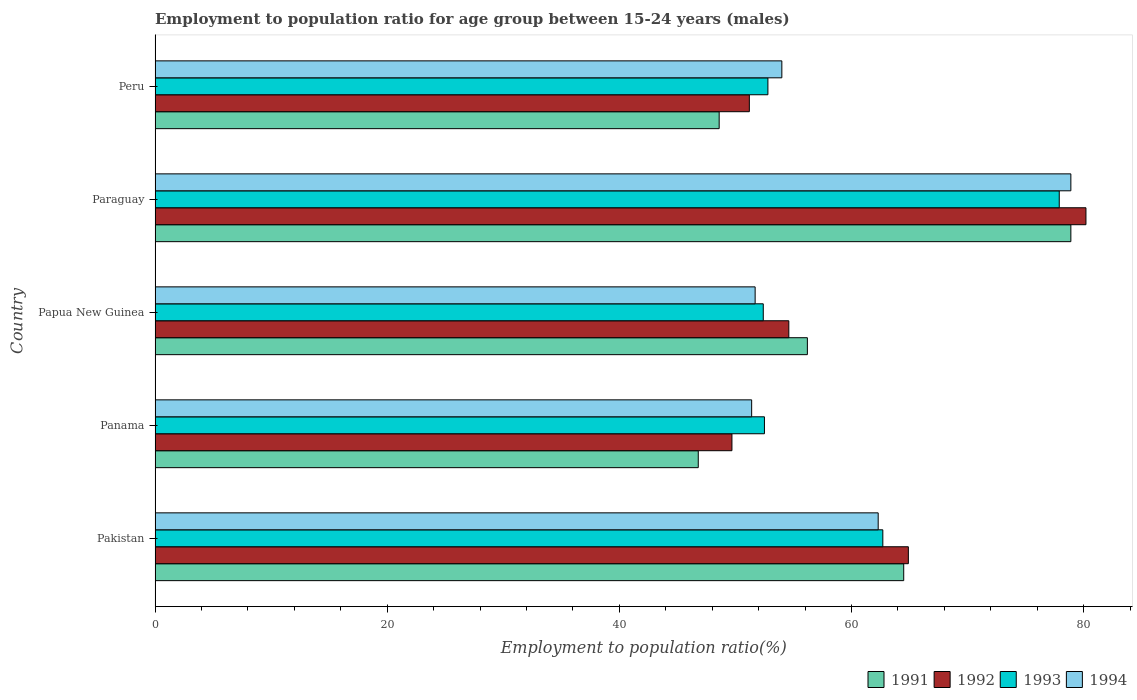How many different coloured bars are there?
Provide a succinct answer. 4. How many groups of bars are there?
Keep it short and to the point. 5. Are the number of bars per tick equal to the number of legend labels?
Keep it short and to the point. Yes. Are the number of bars on each tick of the Y-axis equal?
Provide a succinct answer. Yes. How many bars are there on the 4th tick from the bottom?
Make the answer very short. 4. What is the label of the 2nd group of bars from the top?
Provide a succinct answer. Paraguay. In how many cases, is the number of bars for a given country not equal to the number of legend labels?
Give a very brief answer. 0. What is the employment to population ratio in 1992 in Pakistan?
Keep it short and to the point. 64.9. Across all countries, what is the maximum employment to population ratio in 1991?
Keep it short and to the point. 78.9. Across all countries, what is the minimum employment to population ratio in 1992?
Your response must be concise. 49.7. In which country was the employment to population ratio in 1992 maximum?
Make the answer very short. Paraguay. In which country was the employment to population ratio in 1991 minimum?
Provide a short and direct response. Panama. What is the total employment to population ratio in 1993 in the graph?
Ensure brevity in your answer.  298.3. What is the difference between the employment to population ratio in 1991 in Panama and that in Papua New Guinea?
Your answer should be compact. -9.4. What is the difference between the employment to population ratio in 1994 and employment to population ratio in 1991 in Pakistan?
Make the answer very short. -2.2. In how many countries, is the employment to population ratio in 1993 greater than 16 %?
Make the answer very short. 5. What is the ratio of the employment to population ratio in 1993 in Pakistan to that in Peru?
Your response must be concise. 1.19. Is the employment to population ratio in 1991 in Paraguay less than that in Peru?
Your answer should be very brief. No. Is the difference between the employment to population ratio in 1994 in Papua New Guinea and Paraguay greater than the difference between the employment to population ratio in 1991 in Papua New Guinea and Paraguay?
Make the answer very short. No. What is the difference between the highest and the second highest employment to population ratio in 1994?
Offer a very short reply. 16.6. What is the difference between the highest and the lowest employment to population ratio in 1994?
Ensure brevity in your answer.  27.5. What does the 1st bar from the bottom in Pakistan represents?
Provide a short and direct response. 1991. Are all the bars in the graph horizontal?
Keep it short and to the point. Yes. What is the difference between two consecutive major ticks on the X-axis?
Give a very brief answer. 20. Are the values on the major ticks of X-axis written in scientific E-notation?
Provide a succinct answer. No. Does the graph contain any zero values?
Provide a succinct answer. No. Does the graph contain grids?
Your response must be concise. No. Where does the legend appear in the graph?
Give a very brief answer. Bottom right. How many legend labels are there?
Your response must be concise. 4. What is the title of the graph?
Provide a short and direct response. Employment to population ratio for age group between 15-24 years (males). What is the Employment to population ratio(%) of 1991 in Pakistan?
Give a very brief answer. 64.5. What is the Employment to population ratio(%) in 1992 in Pakistan?
Offer a terse response. 64.9. What is the Employment to population ratio(%) in 1993 in Pakistan?
Make the answer very short. 62.7. What is the Employment to population ratio(%) in 1994 in Pakistan?
Give a very brief answer. 62.3. What is the Employment to population ratio(%) in 1991 in Panama?
Your answer should be very brief. 46.8. What is the Employment to population ratio(%) in 1992 in Panama?
Make the answer very short. 49.7. What is the Employment to population ratio(%) in 1993 in Panama?
Your answer should be very brief. 52.5. What is the Employment to population ratio(%) in 1994 in Panama?
Provide a short and direct response. 51.4. What is the Employment to population ratio(%) of 1991 in Papua New Guinea?
Give a very brief answer. 56.2. What is the Employment to population ratio(%) of 1992 in Papua New Guinea?
Keep it short and to the point. 54.6. What is the Employment to population ratio(%) of 1993 in Papua New Guinea?
Offer a terse response. 52.4. What is the Employment to population ratio(%) of 1994 in Papua New Guinea?
Your response must be concise. 51.7. What is the Employment to population ratio(%) of 1991 in Paraguay?
Offer a terse response. 78.9. What is the Employment to population ratio(%) in 1992 in Paraguay?
Give a very brief answer. 80.2. What is the Employment to population ratio(%) in 1993 in Paraguay?
Make the answer very short. 77.9. What is the Employment to population ratio(%) in 1994 in Paraguay?
Give a very brief answer. 78.9. What is the Employment to population ratio(%) of 1991 in Peru?
Your answer should be very brief. 48.6. What is the Employment to population ratio(%) in 1992 in Peru?
Make the answer very short. 51.2. What is the Employment to population ratio(%) of 1993 in Peru?
Offer a very short reply. 52.8. What is the Employment to population ratio(%) of 1994 in Peru?
Your response must be concise. 54. Across all countries, what is the maximum Employment to population ratio(%) of 1991?
Offer a very short reply. 78.9. Across all countries, what is the maximum Employment to population ratio(%) of 1992?
Ensure brevity in your answer.  80.2. Across all countries, what is the maximum Employment to population ratio(%) of 1993?
Provide a short and direct response. 77.9. Across all countries, what is the maximum Employment to population ratio(%) of 1994?
Offer a very short reply. 78.9. Across all countries, what is the minimum Employment to population ratio(%) in 1991?
Offer a terse response. 46.8. Across all countries, what is the minimum Employment to population ratio(%) in 1992?
Ensure brevity in your answer.  49.7. Across all countries, what is the minimum Employment to population ratio(%) in 1993?
Your answer should be compact. 52.4. Across all countries, what is the minimum Employment to population ratio(%) of 1994?
Provide a short and direct response. 51.4. What is the total Employment to population ratio(%) in 1991 in the graph?
Offer a very short reply. 295. What is the total Employment to population ratio(%) in 1992 in the graph?
Make the answer very short. 300.6. What is the total Employment to population ratio(%) of 1993 in the graph?
Your answer should be very brief. 298.3. What is the total Employment to population ratio(%) in 1994 in the graph?
Ensure brevity in your answer.  298.3. What is the difference between the Employment to population ratio(%) of 1991 in Pakistan and that in Panama?
Ensure brevity in your answer.  17.7. What is the difference between the Employment to population ratio(%) of 1992 in Pakistan and that in Panama?
Provide a short and direct response. 15.2. What is the difference between the Employment to population ratio(%) in 1992 in Pakistan and that in Papua New Guinea?
Ensure brevity in your answer.  10.3. What is the difference between the Employment to population ratio(%) in 1993 in Pakistan and that in Papua New Guinea?
Provide a succinct answer. 10.3. What is the difference between the Employment to population ratio(%) in 1991 in Pakistan and that in Paraguay?
Make the answer very short. -14.4. What is the difference between the Employment to population ratio(%) of 1992 in Pakistan and that in Paraguay?
Ensure brevity in your answer.  -15.3. What is the difference between the Employment to population ratio(%) in 1993 in Pakistan and that in Paraguay?
Offer a very short reply. -15.2. What is the difference between the Employment to population ratio(%) of 1994 in Pakistan and that in Paraguay?
Your answer should be very brief. -16.6. What is the difference between the Employment to population ratio(%) of 1992 in Pakistan and that in Peru?
Make the answer very short. 13.7. What is the difference between the Employment to population ratio(%) of 1993 in Pakistan and that in Peru?
Keep it short and to the point. 9.9. What is the difference between the Employment to population ratio(%) in 1992 in Panama and that in Papua New Guinea?
Your response must be concise. -4.9. What is the difference between the Employment to population ratio(%) in 1993 in Panama and that in Papua New Guinea?
Provide a succinct answer. 0.1. What is the difference between the Employment to population ratio(%) in 1991 in Panama and that in Paraguay?
Provide a short and direct response. -32.1. What is the difference between the Employment to population ratio(%) of 1992 in Panama and that in Paraguay?
Provide a short and direct response. -30.5. What is the difference between the Employment to population ratio(%) in 1993 in Panama and that in Paraguay?
Your answer should be very brief. -25.4. What is the difference between the Employment to population ratio(%) of 1994 in Panama and that in Paraguay?
Ensure brevity in your answer.  -27.5. What is the difference between the Employment to population ratio(%) of 1993 in Panama and that in Peru?
Offer a very short reply. -0.3. What is the difference between the Employment to population ratio(%) in 1994 in Panama and that in Peru?
Provide a succinct answer. -2.6. What is the difference between the Employment to population ratio(%) in 1991 in Papua New Guinea and that in Paraguay?
Your response must be concise. -22.7. What is the difference between the Employment to population ratio(%) of 1992 in Papua New Guinea and that in Paraguay?
Your answer should be very brief. -25.6. What is the difference between the Employment to population ratio(%) in 1993 in Papua New Guinea and that in Paraguay?
Your answer should be very brief. -25.5. What is the difference between the Employment to population ratio(%) in 1994 in Papua New Guinea and that in Paraguay?
Your response must be concise. -27.2. What is the difference between the Employment to population ratio(%) in 1992 in Papua New Guinea and that in Peru?
Offer a very short reply. 3.4. What is the difference between the Employment to population ratio(%) of 1993 in Papua New Guinea and that in Peru?
Your answer should be compact. -0.4. What is the difference between the Employment to population ratio(%) of 1991 in Paraguay and that in Peru?
Your response must be concise. 30.3. What is the difference between the Employment to population ratio(%) of 1993 in Paraguay and that in Peru?
Your answer should be very brief. 25.1. What is the difference between the Employment to population ratio(%) in 1994 in Paraguay and that in Peru?
Offer a very short reply. 24.9. What is the difference between the Employment to population ratio(%) of 1991 in Pakistan and the Employment to population ratio(%) of 1992 in Panama?
Give a very brief answer. 14.8. What is the difference between the Employment to population ratio(%) in 1991 in Pakistan and the Employment to population ratio(%) in 1993 in Panama?
Provide a succinct answer. 12. What is the difference between the Employment to population ratio(%) of 1992 in Pakistan and the Employment to population ratio(%) of 1993 in Panama?
Your answer should be very brief. 12.4. What is the difference between the Employment to population ratio(%) in 1992 in Pakistan and the Employment to population ratio(%) in 1994 in Panama?
Provide a succinct answer. 13.5. What is the difference between the Employment to population ratio(%) of 1991 in Pakistan and the Employment to population ratio(%) of 1992 in Papua New Guinea?
Make the answer very short. 9.9. What is the difference between the Employment to population ratio(%) of 1992 in Pakistan and the Employment to population ratio(%) of 1993 in Papua New Guinea?
Ensure brevity in your answer.  12.5. What is the difference between the Employment to population ratio(%) in 1992 in Pakistan and the Employment to population ratio(%) in 1994 in Papua New Guinea?
Your answer should be compact. 13.2. What is the difference between the Employment to population ratio(%) of 1991 in Pakistan and the Employment to population ratio(%) of 1992 in Paraguay?
Keep it short and to the point. -15.7. What is the difference between the Employment to population ratio(%) of 1991 in Pakistan and the Employment to population ratio(%) of 1993 in Paraguay?
Give a very brief answer. -13.4. What is the difference between the Employment to population ratio(%) in 1991 in Pakistan and the Employment to population ratio(%) in 1994 in Paraguay?
Offer a terse response. -14.4. What is the difference between the Employment to population ratio(%) of 1992 in Pakistan and the Employment to population ratio(%) of 1993 in Paraguay?
Offer a terse response. -13. What is the difference between the Employment to population ratio(%) of 1993 in Pakistan and the Employment to population ratio(%) of 1994 in Paraguay?
Ensure brevity in your answer.  -16.2. What is the difference between the Employment to population ratio(%) of 1991 in Pakistan and the Employment to population ratio(%) of 1993 in Peru?
Your response must be concise. 11.7. What is the difference between the Employment to population ratio(%) of 1993 in Pakistan and the Employment to population ratio(%) of 1994 in Peru?
Offer a terse response. 8.7. What is the difference between the Employment to population ratio(%) in 1991 in Panama and the Employment to population ratio(%) in 1994 in Papua New Guinea?
Offer a terse response. -4.9. What is the difference between the Employment to population ratio(%) in 1992 in Panama and the Employment to population ratio(%) in 1993 in Papua New Guinea?
Give a very brief answer. -2.7. What is the difference between the Employment to population ratio(%) in 1991 in Panama and the Employment to population ratio(%) in 1992 in Paraguay?
Give a very brief answer. -33.4. What is the difference between the Employment to population ratio(%) in 1991 in Panama and the Employment to population ratio(%) in 1993 in Paraguay?
Keep it short and to the point. -31.1. What is the difference between the Employment to population ratio(%) of 1991 in Panama and the Employment to population ratio(%) of 1994 in Paraguay?
Your answer should be very brief. -32.1. What is the difference between the Employment to population ratio(%) of 1992 in Panama and the Employment to population ratio(%) of 1993 in Paraguay?
Your answer should be compact. -28.2. What is the difference between the Employment to population ratio(%) in 1992 in Panama and the Employment to population ratio(%) in 1994 in Paraguay?
Make the answer very short. -29.2. What is the difference between the Employment to population ratio(%) of 1993 in Panama and the Employment to population ratio(%) of 1994 in Paraguay?
Your answer should be very brief. -26.4. What is the difference between the Employment to population ratio(%) in 1991 in Panama and the Employment to population ratio(%) in 1993 in Peru?
Your answer should be compact. -6. What is the difference between the Employment to population ratio(%) in 1992 in Panama and the Employment to population ratio(%) in 1994 in Peru?
Provide a short and direct response. -4.3. What is the difference between the Employment to population ratio(%) in 1993 in Panama and the Employment to population ratio(%) in 1994 in Peru?
Offer a very short reply. -1.5. What is the difference between the Employment to population ratio(%) in 1991 in Papua New Guinea and the Employment to population ratio(%) in 1992 in Paraguay?
Offer a terse response. -24. What is the difference between the Employment to population ratio(%) of 1991 in Papua New Guinea and the Employment to population ratio(%) of 1993 in Paraguay?
Offer a terse response. -21.7. What is the difference between the Employment to population ratio(%) of 1991 in Papua New Guinea and the Employment to population ratio(%) of 1994 in Paraguay?
Your response must be concise. -22.7. What is the difference between the Employment to population ratio(%) in 1992 in Papua New Guinea and the Employment to population ratio(%) in 1993 in Paraguay?
Ensure brevity in your answer.  -23.3. What is the difference between the Employment to population ratio(%) in 1992 in Papua New Guinea and the Employment to population ratio(%) in 1994 in Paraguay?
Give a very brief answer. -24.3. What is the difference between the Employment to population ratio(%) in 1993 in Papua New Guinea and the Employment to population ratio(%) in 1994 in Paraguay?
Provide a succinct answer. -26.5. What is the difference between the Employment to population ratio(%) in 1991 in Papua New Guinea and the Employment to population ratio(%) in 1993 in Peru?
Your response must be concise. 3.4. What is the difference between the Employment to population ratio(%) in 1992 in Papua New Guinea and the Employment to population ratio(%) in 1994 in Peru?
Provide a succinct answer. 0.6. What is the difference between the Employment to population ratio(%) of 1993 in Papua New Guinea and the Employment to population ratio(%) of 1994 in Peru?
Offer a terse response. -1.6. What is the difference between the Employment to population ratio(%) in 1991 in Paraguay and the Employment to population ratio(%) in 1992 in Peru?
Your answer should be compact. 27.7. What is the difference between the Employment to population ratio(%) in 1991 in Paraguay and the Employment to population ratio(%) in 1993 in Peru?
Your response must be concise. 26.1. What is the difference between the Employment to population ratio(%) of 1991 in Paraguay and the Employment to population ratio(%) of 1994 in Peru?
Your answer should be compact. 24.9. What is the difference between the Employment to population ratio(%) of 1992 in Paraguay and the Employment to population ratio(%) of 1993 in Peru?
Your answer should be very brief. 27.4. What is the difference between the Employment to population ratio(%) of 1992 in Paraguay and the Employment to population ratio(%) of 1994 in Peru?
Ensure brevity in your answer.  26.2. What is the difference between the Employment to population ratio(%) in 1993 in Paraguay and the Employment to population ratio(%) in 1994 in Peru?
Keep it short and to the point. 23.9. What is the average Employment to population ratio(%) in 1992 per country?
Your answer should be very brief. 60.12. What is the average Employment to population ratio(%) of 1993 per country?
Make the answer very short. 59.66. What is the average Employment to population ratio(%) in 1994 per country?
Give a very brief answer. 59.66. What is the difference between the Employment to population ratio(%) of 1991 and Employment to population ratio(%) of 1993 in Pakistan?
Make the answer very short. 1.8. What is the difference between the Employment to population ratio(%) in 1991 and Employment to population ratio(%) in 1994 in Pakistan?
Your answer should be very brief. 2.2. What is the difference between the Employment to population ratio(%) in 1992 and Employment to population ratio(%) in 1993 in Pakistan?
Keep it short and to the point. 2.2. What is the difference between the Employment to population ratio(%) in 1992 and Employment to population ratio(%) in 1994 in Pakistan?
Ensure brevity in your answer.  2.6. What is the difference between the Employment to population ratio(%) in 1993 and Employment to population ratio(%) in 1994 in Pakistan?
Your response must be concise. 0.4. What is the difference between the Employment to population ratio(%) of 1991 and Employment to population ratio(%) of 1994 in Panama?
Make the answer very short. -4.6. What is the difference between the Employment to population ratio(%) in 1992 and Employment to population ratio(%) in 1993 in Panama?
Provide a short and direct response. -2.8. What is the difference between the Employment to population ratio(%) in 1991 and Employment to population ratio(%) in 1993 in Papua New Guinea?
Provide a succinct answer. 3.8. What is the difference between the Employment to population ratio(%) in 1991 and Employment to population ratio(%) in 1994 in Papua New Guinea?
Provide a succinct answer. 4.5. What is the difference between the Employment to population ratio(%) of 1992 and Employment to population ratio(%) of 1994 in Papua New Guinea?
Your answer should be very brief. 2.9. What is the difference between the Employment to population ratio(%) in 1993 and Employment to population ratio(%) in 1994 in Papua New Guinea?
Your response must be concise. 0.7. What is the difference between the Employment to population ratio(%) of 1991 and Employment to population ratio(%) of 1994 in Paraguay?
Offer a very short reply. 0. What is the difference between the Employment to population ratio(%) in 1992 and Employment to population ratio(%) in 1994 in Paraguay?
Offer a very short reply. 1.3. What is the difference between the Employment to population ratio(%) of 1993 and Employment to population ratio(%) of 1994 in Paraguay?
Give a very brief answer. -1. What is the difference between the Employment to population ratio(%) of 1991 and Employment to population ratio(%) of 1994 in Peru?
Your response must be concise. -5.4. What is the difference between the Employment to population ratio(%) of 1992 and Employment to population ratio(%) of 1994 in Peru?
Keep it short and to the point. -2.8. What is the ratio of the Employment to population ratio(%) in 1991 in Pakistan to that in Panama?
Offer a very short reply. 1.38. What is the ratio of the Employment to population ratio(%) of 1992 in Pakistan to that in Panama?
Offer a very short reply. 1.31. What is the ratio of the Employment to population ratio(%) of 1993 in Pakistan to that in Panama?
Make the answer very short. 1.19. What is the ratio of the Employment to population ratio(%) of 1994 in Pakistan to that in Panama?
Provide a succinct answer. 1.21. What is the ratio of the Employment to population ratio(%) of 1991 in Pakistan to that in Papua New Guinea?
Your answer should be very brief. 1.15. What is the ratio of the Employment to population ratio(%) in 1992 in Pakistan to that in Papua New Guinea?
Offer a very short reply. 1.19. What is the ratio of the Employment to population ratio(%) of 1993 in Pakistan to that in Papua New Guinea?
Ensure brevity in your answer.  1.2. What is the ratio of the Employment to population ratio(%) in 1994 in Pakistan to that in Papua New Guinea?
Provide a succinct answer. 1.21. What is the ratio of the Employment to population ratio(%) in 1991 in Pakistan to that in Paraguay?
Provide a short and direct response. 0.82. What is the ratio of the Employment to population ratio(%) of 1992 in Pakistan to that in Paraguay?
Offer a terse response. 0.81. What is the ratio of the Employment to population ratio(%) of 1993 in Pakistan to that in Paraguay?
Your response must be concise. 0.8. What is the ratio of the Employment to population ratio(%) in 1994 in Pakistan to that in Paraguay?
Your answer should be compact. 0.79. What is the ratio of the Employment to population ratio(%) in 1991 in Pakistan to that in Peru?
Offer a terse response. 1.33. What is the ratio of the Employment to population ratio(%) in 1992 in Pakistan to that in Peru?
Your answer should be compact. 1.27. What is the ratio of the Employment to population ratio(%) of 1993 in Pakistan to that in Peru?
Your answer should be compact. 1.19. What is the ratio of the Employment to population ratio(%) in 1994 in Pakistan to that in Peru?
Offer a very short reply. 1.15. What is the ratio of the Employment to population ratio(%) of 1991 in Panama to that in Papua New Guinea?
Provide a succinct answer. 0.83. What is the ratio of the Employment to population ratio(%) in 1992 in Panama to that in Papua New Guinea?
Your answer should be very brief. 0.91. What is the ratio of the Employment to population ratio(%) in 1994 in Panama to that in Papua New Guinea?
Provide a short and direct response. 0.99. What is the ratio of the Employment to population ratio(%) of 1991 in Panama to that in Paraguay?
Your response must be concise. 0.59. What is the ratio of the Employment to population ratio(%) of 1992 in Panama to that in Paraguay?
Offer a very short reply. 0.62. What is the ratio of the Employment to population ratio(%) of 1993 in Panama to that in Paraguay?
Keep it short and to the point. 0.67. What is the ratio of the Employment to population ratio(%) of 1994 in Panama to that in Paraguay?
Offer a terse response. 0.65. What is the ratio of the Employment to population ratio(%) in 1991 in Panama to that in Peru?
Your answer should be very brief. 0.96. What is the ratio of the Employment to population ratio(%) of 1992 in Panama to that in Peru?
Ensure brevity in your answer.  0.97. What is the ratio of the Employment to population ratio(%) of 1993 in Panama to that in Peru?
Offer a very short reply. 0.99. What is the ratio of the Employment to population ratio(%) of 1994 in Panama to that in Peru?
Your response must be concise. 0.95. What is the ratio of the Employment to population ratio(%) of 1991 in Papua New Guinea to that in Paraguay?
Ensure brevity in your answer.  0.71. What is the ratio of the Employment to population ratio(%) in 1992 in Papua New Guinea to that in Paraguay?
Your response must be concise. 0.68. What is the ratio of the Employment to population ratio(%) in 1993 in Papua New Guinea to that in Paraguay?
Ensure brevity in your answer.  0.67. What is the ratio of the Employment to population ratio(%) of 1994 in Papua New Guinea to that in Paraguay?
Keep it short and to the point. 0.66. What is the ratio of the Employment to population ratio(%) of 1991 in Papua New Guinea to that in Peru?
Offer a very short reply. 1.16. What is the ratio of the Employment to population ratio(%) in 1992 in Papua New Guinea to that in Peru?
Your answer should be very brief. 1.07. What is the ratio of the Employment to population ratio(%) in 1994 in Papua New Guinea to that in Peru?
Offer a very short reply. 0.96. What is the ratio of the Employment to population ratio(%) of 1991 in Paraguay to that in Peru?
Give a very brief answer. 1.62. What is the ratio of the Employment to population ratio(%) in 1992 in Paraguay to that in Peru?
Keep it short and to the point. 1.57. What is the ratio of the Employment to population ratio(%) of 1993 in Paraguay to that in Peru?
Provide a short and direct response. 1.48. What is the ratio of the Employment to population ratio(%) of 1994 in Paraguay to that in Peru?
Offer a very short reply. 1.46. What is the difference between the highest and the second highest Employment to population ratio(%) of 1991?
Ensure brevity in your answer.  14.4. What is the difference between the highest and the second highest Employment to population ratio(%) in 1993?
Keep it short and to the point. 15.2. What is the difference between the highest and the lowest Employment to population ratio(%) in 1991?
Your answer should be compact. 32.1. What is the difference between the highest and the lowest Employment to population ratio(%) of 1992?
Your response must be concise. 30.5. What is the difference between the highest and the lowest Employment to population ratio(%) in 1993?
Keep it short and to the point. 25.5. 